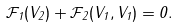Convert formula to latex. <formula><loc_0><loc_0><loc_500><loc_500>\mathcal { F } _ { 1 } ( V _ { 2 } ) + \mathcal { F } _ { 2 } ( V _ { 1 } , V _ { 1 } ) = 0 .</formula> 